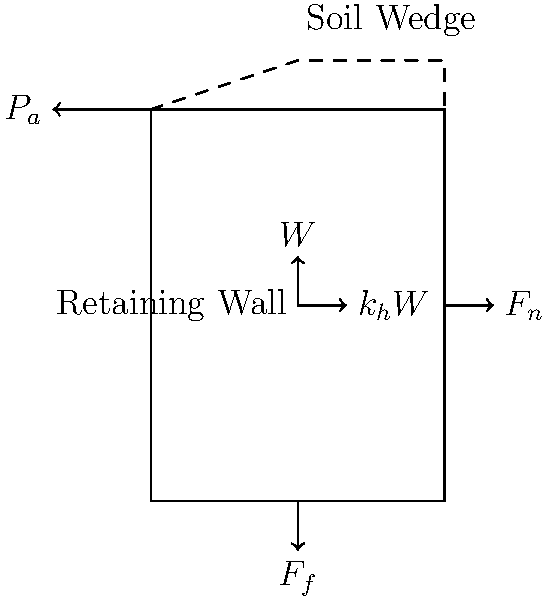During an emergency situation, you are coordinating with local engineers to assess the stability of a retaining wall that protects an important embassy building. The wall is subjected to seismic forces due to an earthquake. Given the force diagram, how would you determine if the retaining wall is stable against sliding during the earthquake? To determine if the retaining wall is stable against sliding during an earthquake, we need to follow these steps:

1. Identify the forces acting on the wall:
   - $W$: Weight of the wall
   - $P_a$: Active earth pressure from the soil
   - $k_h W$: Horizontal seismic force (where $k_h$ is the horizontal seismic coefficient)
   - $F_n$: Normal force from the base
   - $F_f$: Friction force at the base

2. Establish the equilibrium equations:
   Horizontal: $\sum F_x = 0$: $P_a + k_h W - F_f = 0$
   Vertical: $\sum F_y = 0$: $W - F_n = 0$

3. Calculate the friction force:
   $F_f = \mu F_n = \mu W$, where $\mu$ is the coefficient of friction between the wall and the base.

4. Determine the factor of safety against sliding:
   $FS_{sliding} = \frac{\text{Resisting Force}}{\text{Driving Force}} = \frac{F_f}{P_a + k_h W} = \frac{\mu W}{P_a + k_h W}$

5. Check stability criterion:
   If $FS_{sliding} > 1.5$ (typically), the wall is considered stable against sliding.

6. If given specific values, calculate the factor of safety and compare it to the required value.

7. Consider additional factors such as overturning stability and bearing capacity of the foundation.
Answer: Calculate $FS_{sliding} = \frac{\mu W}{P_a + k_h W}$ and ensure it's greater than 1.5 for stability. 